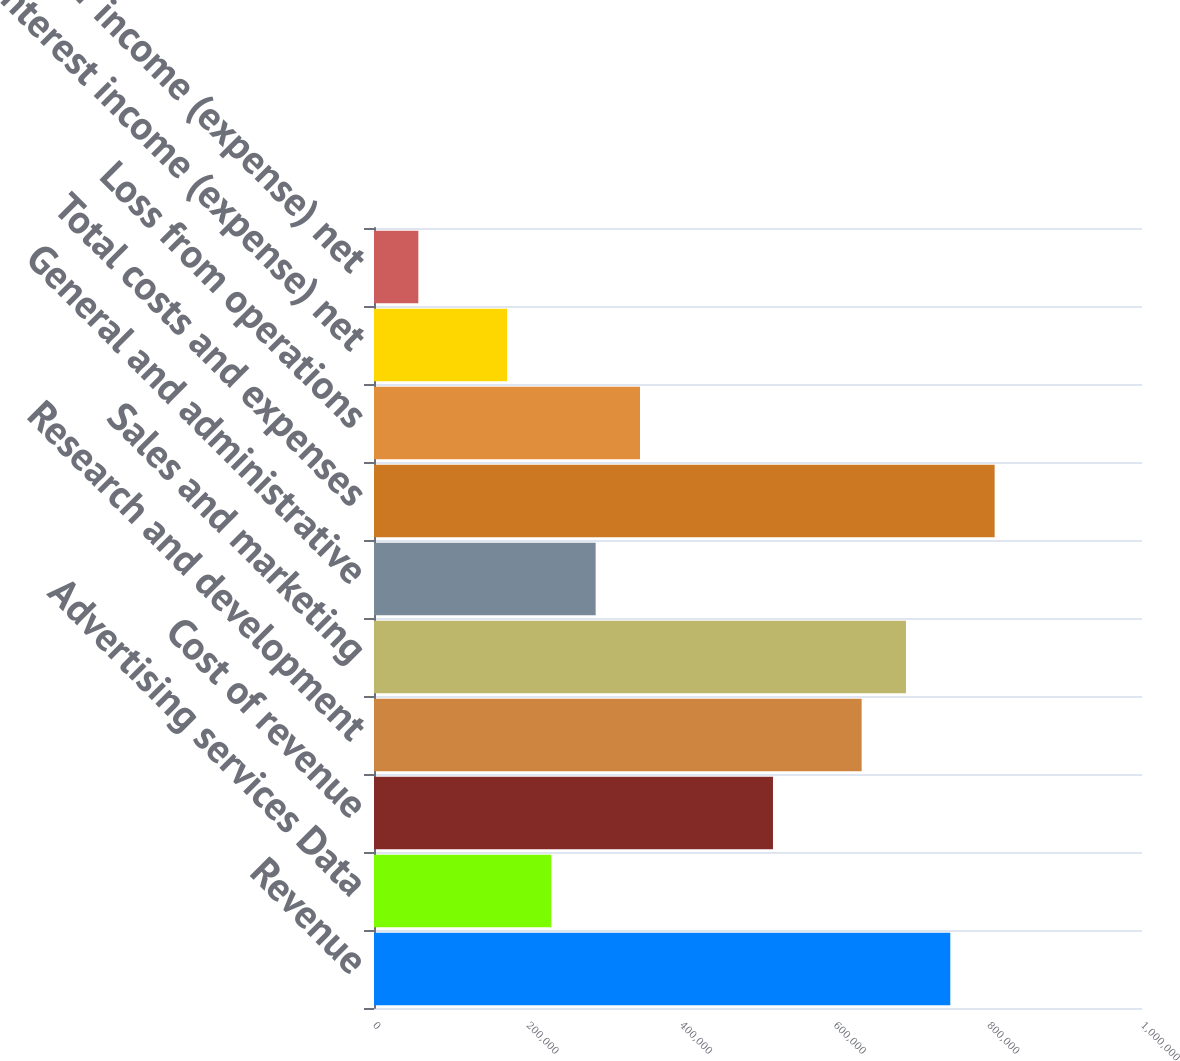Convert chart to OTSL. <chart><loc_0><loc_0><loc_500><loc_500><bar_chart><fcel>Revenue<fcel>Advertising services Data<fcel>Cost of revenue<fcel>Research and development<fcel>Sales and marketing<fcel>General and administrative<fcel>Total costs and expenses<fcel>Loss from operations<fcel>Interest income (expense) net<fcel>Other income (expense) net<nl><fcel>750400<fcel>230893<fcel>519508<fcel>634954<fcel>692677<fcel>288616<fcel>808123<fcel>346339<fcel>173169<fcel>57723.3<nl></chart> 